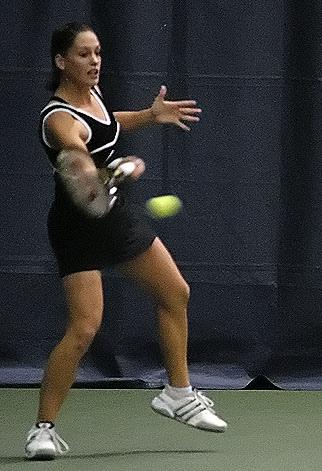What sport is this?
Concise answer only. Tennis. Who is in the photo?
Concise answer only. Tennis player. Where is the player?
Write a very short answer. Tennis court. 